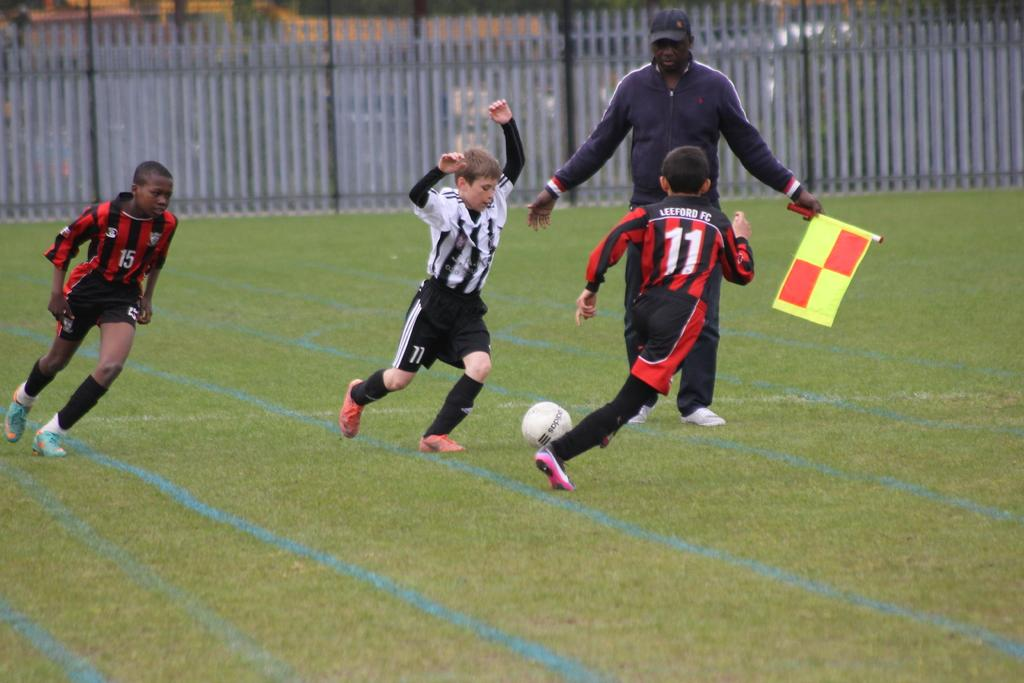How many children are present in the image? There are three children in the image. What are the children doing in the image? The children are playing on the ground. What object can be seen in the image that they might be playing with? There is a ball in the image. What type of surface are the children playing on? There is grass in the image, which suggests they are playing on a grassy area. What can be seen in the background of the image? There is a fence in the background of the image. Can you tell me how many bears are visible in the image? There are no bears present in the image; it features three children playing on the grass. What type of glass object can be seen in the image? There is no glass object present in the image. 